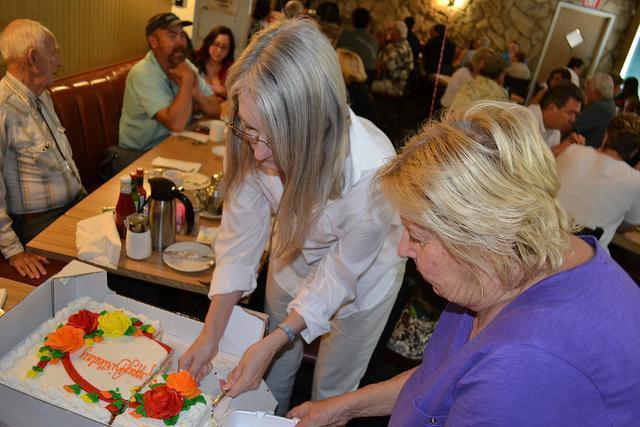How many people can you see?
Give a very brief answer. 8. How many bowls are there?
Give a very brief answer. 0. 